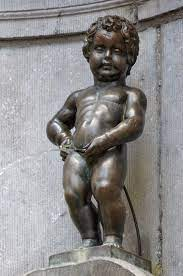What are some of the most notable costumes of the Manneken Pis, and what do they signify? The Manneken Pis has an extensive wardrobe, reflective of various cultures, professions, and festivities. Among the most notable is the costume of Saint Nicholas, worn during the Christmas season, symbolizing kindness and generosity. Another significant outfit is that of a firefighter, worn to honor and show solidarity with the fire brigade. Each costume is meticulously crafted and often presented during major events, parades, or to acknowledge certain dignitaries or groups, enhancing the statue’s role as a participant in city life and an active cultural symbol. 